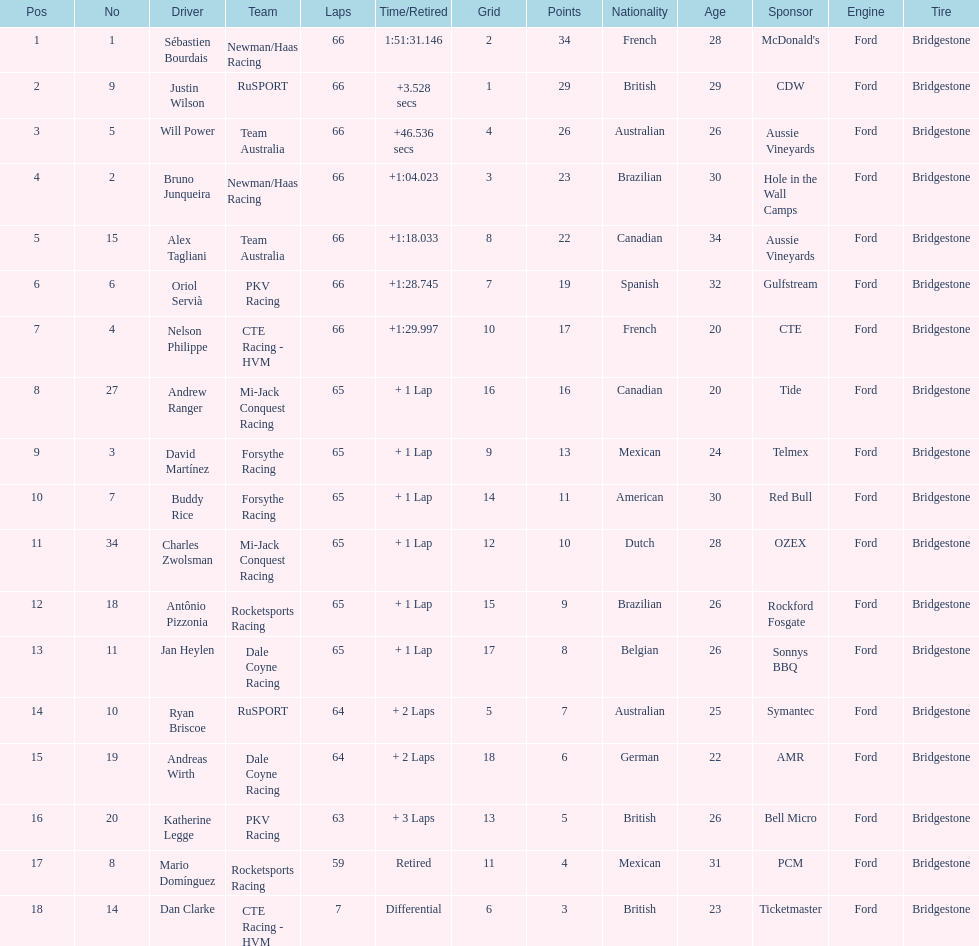Parse the full table. {'header': ['Pos', 'No', 'Driver', 'Team', 'Laps', 'Time/Retired', 'Grid', 'Points', 'Nationality', 'Age', 'Sponsor', 'Engine', 'Tire'], 'rows': [['1', '1', 'Sébastien Bourdais', 'Newman/Haas Racing', '66', '1:51:31.146', '2', '34', 'French', '28', "McDonald's", 'Ford', 'Bridgestone'], ['2', '9', 'Justin Wilson', 'RuSPORT', '66', '+3.528 secs', '1', '29', 'British', '29', 'CDW', 'Ford', 'Bridgestone'], ['3', '5', 'Will Power', 'Team Australia', '66', '+46.536 secs', '4', '26', 'Australian', '26', 'Aussie Vineyards', 'Ford', 'Bridgestone'], ['4', '2', 'Bruno Junqueira', 'Newman/Haas Racing', '66', '+1:04.023', '3', '23', 'Brazilian', '30', 'Hole in the Wall Camps', 'Ford', 'Bridgestone'], ['5', '15', 'Alex Tagliani', 'Team Australia', '66', '+1:18.033', '8', '22', 'Canadian', '34', 'Aussie Vineyards', 'Ford', 'Bridgestone'], ['6', '6', 'Oriol Servià', 'PKV Racing', '66', '+1:28.745', '7', '19', 'Spanish', '32', 'Gulfstream', 'Ford', 'Bridgestone'], ['7', '4', 'Nelson Philippe', 'CTE Racing - HVM', '66', '+1:29.997', '10', '17', 'French', '20', 'CTE', 'Ford', 'Bridgestone'], ['8', '27', 'Andrew Ranger', 'Mi-Jack Conquest Racing', '65', '+ 1 Lap', '16', '16', 'Canadian', '20', 'Tide', 'Ford', 'Bridgestone'], ['9', '3', 'David Martínez', 'Forsythe Racing', '65', '+ 1 Lap', '9', '13', 'Mexican', '24', 'Telmex', 'Ford', 'Bridgestone'], ['10', '7', 'Buddy Rice', 'Forsythe Racing', '65', '+ 1 Lap', '14', '11', 'American', '30', 'Red Bull', 'Ford', 'Bridgestone'], ['11', '34', 'Charles Zwolsman', 'Mi-Jack Conquest Racing', '65', '+ 1 Lap', '12', '10', 'Dutch', '28', 'OZEX', 'Ford', 'Bridgestone'], ['12', '18', 'Antônio Pizzonia', 'Rocketsports Racing', '65', '+ 1 Lap', '15', '9', 'Brazilian', '26', 'Rockford Fosgate', 'Ford', 'Bridgestone'], ['13', '11', 'Jan Heylen', 'Dale Coyne Racing', '65', '+ 1 Lap', '17', '8', 'Belgian', '26', 'Sonnys BBQ', 'Ford', 'Bridgestone'], ['14', '10', 'Ryan Briscoe', 'RuSPORT', '64', '+ 2 Laps', '5', '7', 'Australian', '25', 'Symantec', 'Ford', 'Bridgestone'], ['15', '19', 'Andreas Wirth', 'Dale Coyne Racing', '64', '+ 2 Laps', '18', '6', 'German', '22', 'AMR', 'Ford', 'Bridgestone'], ['16', '20', 'Katherine Legge', 'PKV Racing', '63', '+ 3 Laps', '13', '5', 'British', '26', 'Bell Micro', 'Ford', 'Bridgestone'], ['17', '8', 'Mario Domínguez', 'Rocketsports Racing', '59', 'Retired', '11', '4', 'Mexican', '31', 'PCM', 'Ford', 'Bridgestone'], ['18', '14', 'Dan Clarke', 'CTE Racing - HVM', '7', 'Differential', '6', '3', 'British', '23', 'Ticketmaster', 'Ford', 'Bridgestone']]} Rice finished 10th. who finished next? Charles Zwolsman. 